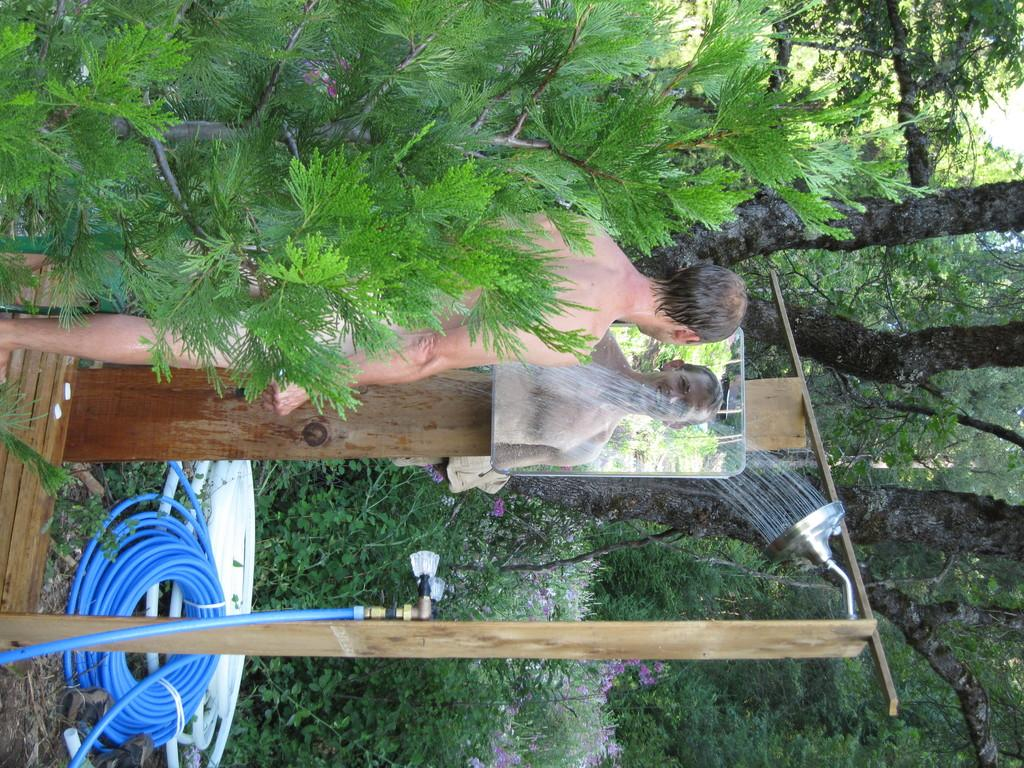What is the person in the image doing? The person is looking in a mirror. What can be seen in the background of the image? There are trees and plants in the image. What objects are related to water in the image? There is a pipe, a tap, and a shower in the image. What other structures are present in the image? There are poles in the image. Can you see a dog playing with a skate during recess in the image? There is no dog or skate present in the image, and the concept of recess is not relevant to the scene depicted. 